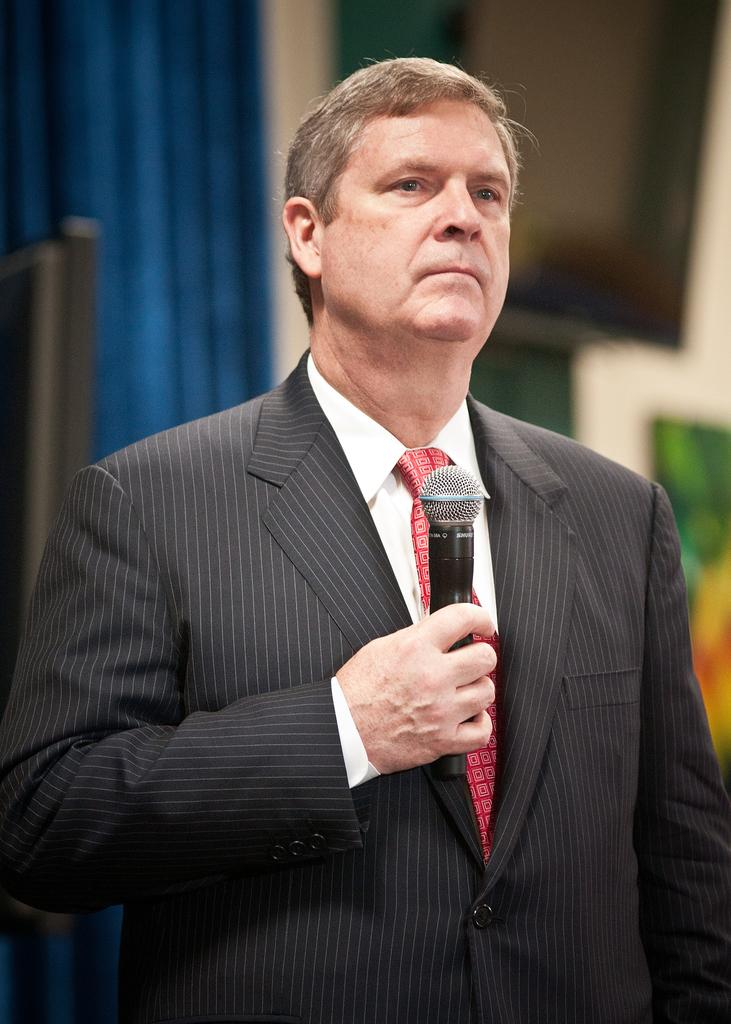What is the main subject of the image? There is a man in the image. What is the man wearing? The man is wearing a black blazer, a white shirt, and a red tie. What is the man holding in the image? The man is holding a microphone. What can be seen in the background of the image? There is a curtain in the background of the image. What type of structure is being attacked by the man in the image? There is no indication in the image that the man is attacking any structure. 